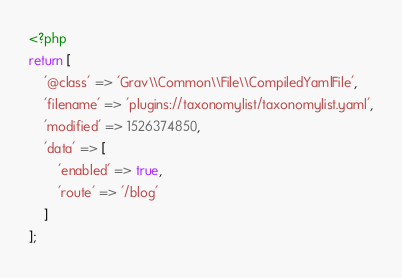<code> <loc_0><loc_0><loc_500><loc_500><_PHP_><?php
return [
    '@class' => 'Grav\\Common\\File\\CompiledYamlFile',
    'filename' => 'plugins://taxonomylist/taxonomylist.yaml',
    'modified' => 1526374850,
    'data' => [
        'enabled' => true,
        'route' => '/blog'
    ]
];
</code> 